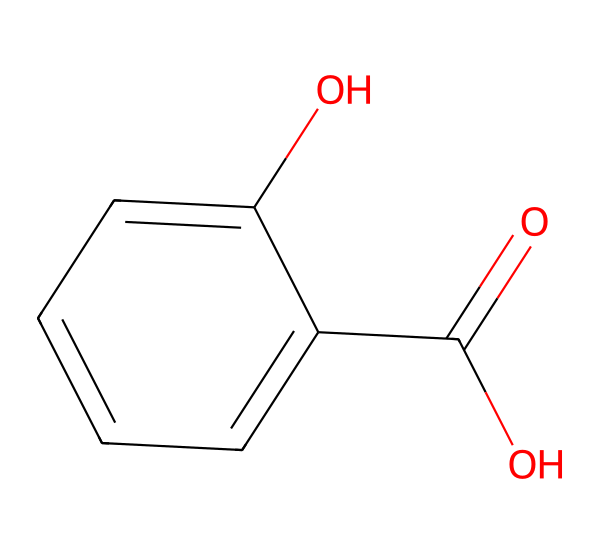What is the name of this acid? The chemical structure represents salicylic acid, which is recognized due to the presence of the carboxylic acid functional group (–COOH) attached to a benzene ring.
Answer: salicylic acid How many carbon atoms are in salicylic acid? By examining the structure, there are six carbon atoms in the benzene ring and one carbon from the carboxylic acid group, making a total of seven.
Answer: 7 What kind of compound is salicylic acid classified as? Salicylic acid is classified as a phenolic acid because it has a hydroxyl group (–OH) attached to a benzene ring and also possesses a carboxylic acid group (–COOH).
Answer: phenolic acid What is the pH of salicylic acid in solution? Salicylic acid is a weak acid, typically having a pH range around 3 to 4 when in solution, due to partial ionization of the carboxylic acid group.
Answer: 3 to 4 How many functional groups are present in salicylic acid? The structure of salicylic acid includes two functional groups: a carboxylic acid and a hydroxyl group, which are both essential for its biological activity and properties.
Answer: 2 Does salicylic acid have antibacterial properties? Yes, salicylic acid exhibits antibacterial properties, particularly effective against certain bacteria that contribute to acne, due to its ability to exfoliate and penetrate the pores.
Answer: yes What skin condition is salicylic acid commonly used to treat? Salicylic acid is most commonly used to treat acne, as it helps remove dead skin cells and reduce inflammation.
Answer: acne 